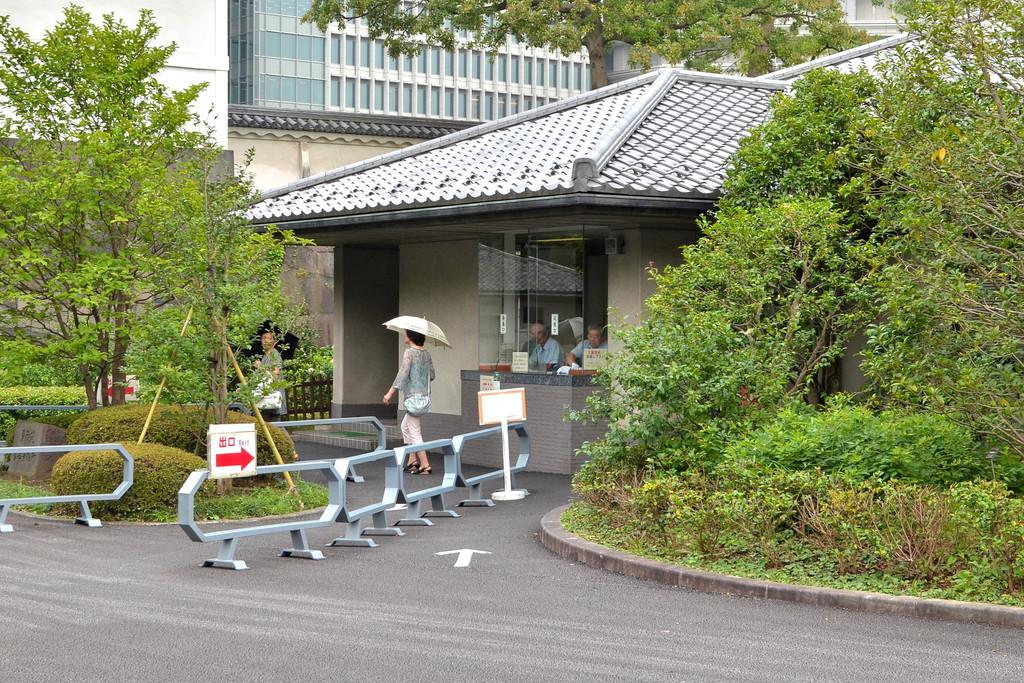What type of structures can be seen in the image? There are buildings in the image. What natural elements are present in the image? There are trees in the image. Are there any living beings visible in the image? Yes, there are people visible in the image. What objects can be seen in the image that are not structures or natural elements? There are boards in the image. What type of vegetation, besides trees, can be seen in the image? There are bushes in the image. How many buns are being held by the cows in the image? There are no cows or buns present in the image. What type of frozen water formation can be seen hanging from the trees in the image? There are no icicles or frozen water formations visible in the image. 